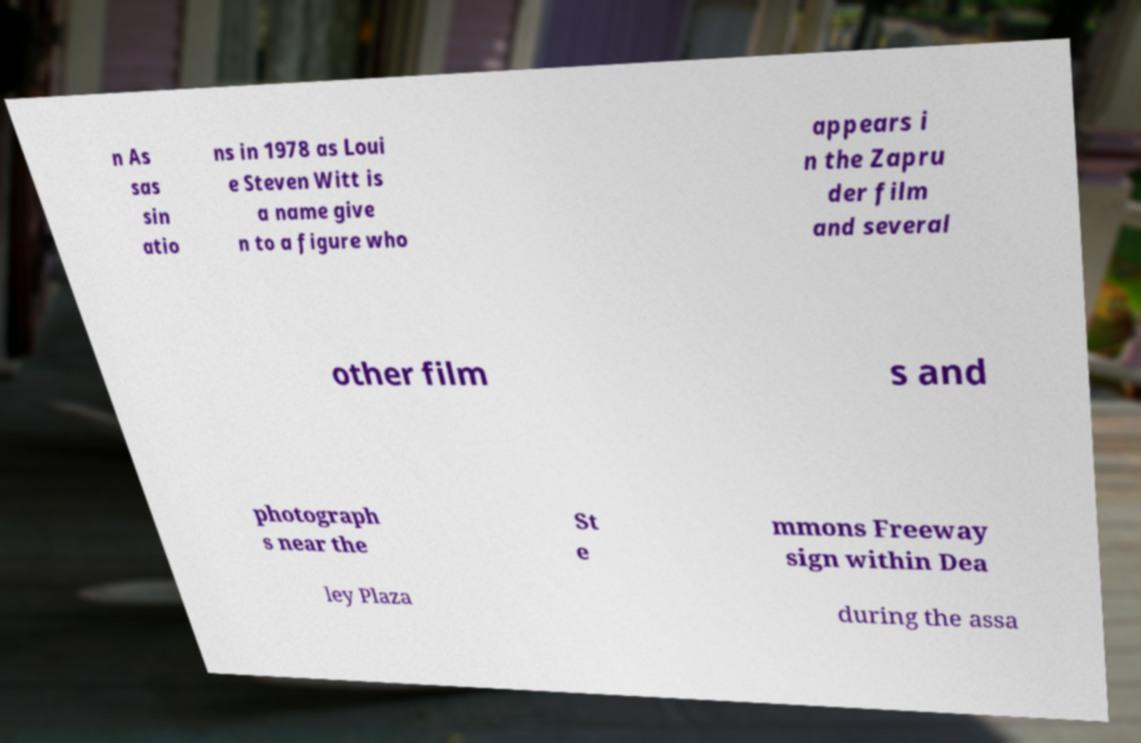For documentation purposes, I need the text within this image transcribed. Could you provide that? n As sas sin atio ns in 1978 as Loui e Steven Witt is a name give n to a figure who appears i n the Zapru der film and several other film s and photograph s near the St e mmons Freeway sign within Dea ley Plaza during the assa 